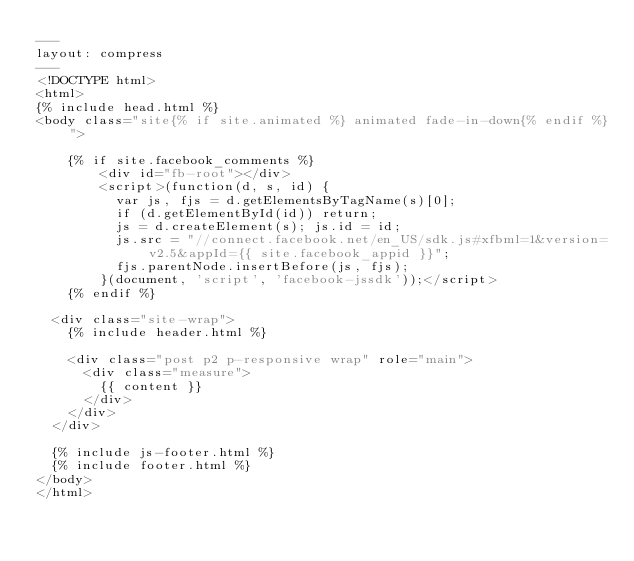<code> <loc_0><loc_0><loc_500><loc_500><_HTML_>---
layout: compress
---
<!DOCTYPE html>
<html>
{% include head.html %}
<body class="site{% if site.animated %} animated fade-in-down{% endif %}">

	{% if site.facebook_comments %}
		<div id="fb-root"></div>
		<script>(function(d, s, id) {
		  var js, fjs = d.getElementsByTagName(s)[0];
		  if (d.getElementById(id)) return;
		  js = d.createElement(s); js.id = id;
		  js.src = "//connect.facebook.net/en_US/sdk.js#xfbml=1&version=v2.5&appId={{ site.facebook_appid }}";
		  fjs.parentNode.insertBefore(js, fjs);
		}(document, 'script', 'facebook-jssdk'));</script>
	{% endif %}

  <div class="site-wrap">
    {% include header.html %}

    <div class="post p2 p-responsive wrap" role="main">
      <div class="measure">
        {{ content }}
      </div>
    </div>
  </div>

  {% include js-footer.html %}
  {% include footer.html %}
</body>
</html>
</code> 